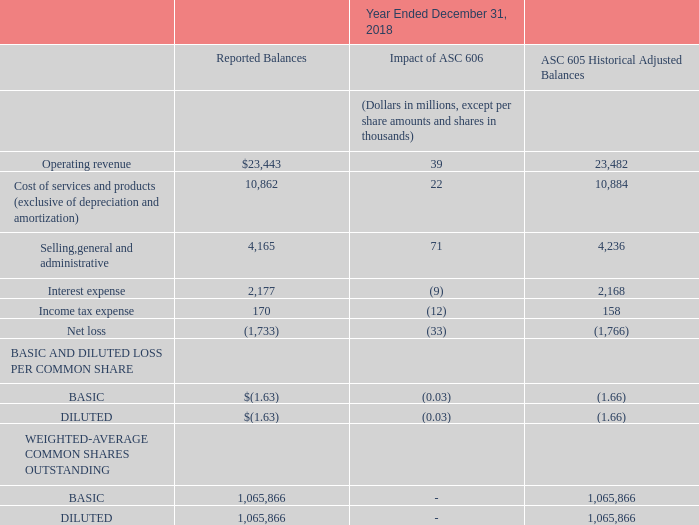(5) Revenue Recognition
The following tables present our reported results under ASC 606 and a reconciliation to results using the historical accounting method:
The table presents the reported results including the impact of what? Asc 606. What method is used for the reconciliation of results? Historical accounting method. What is the Reported Balances operating revenue?
Answer scale should be: million. $23,443. How many types of weighted-average common shares outstanding are there? Basic##Diluted
Answer: 2. What is the sum of interest expense and income tax expense under the ASC 605 Historical Adjusted Balances?
Answer scale should be: million. 2,168+158
Answer: 2326. What is the average income tax expense under reported balances and ASC 605 Historical Adjusted Balances?
Answer scale should be: million. (170+158)/2
Answer: 164. 